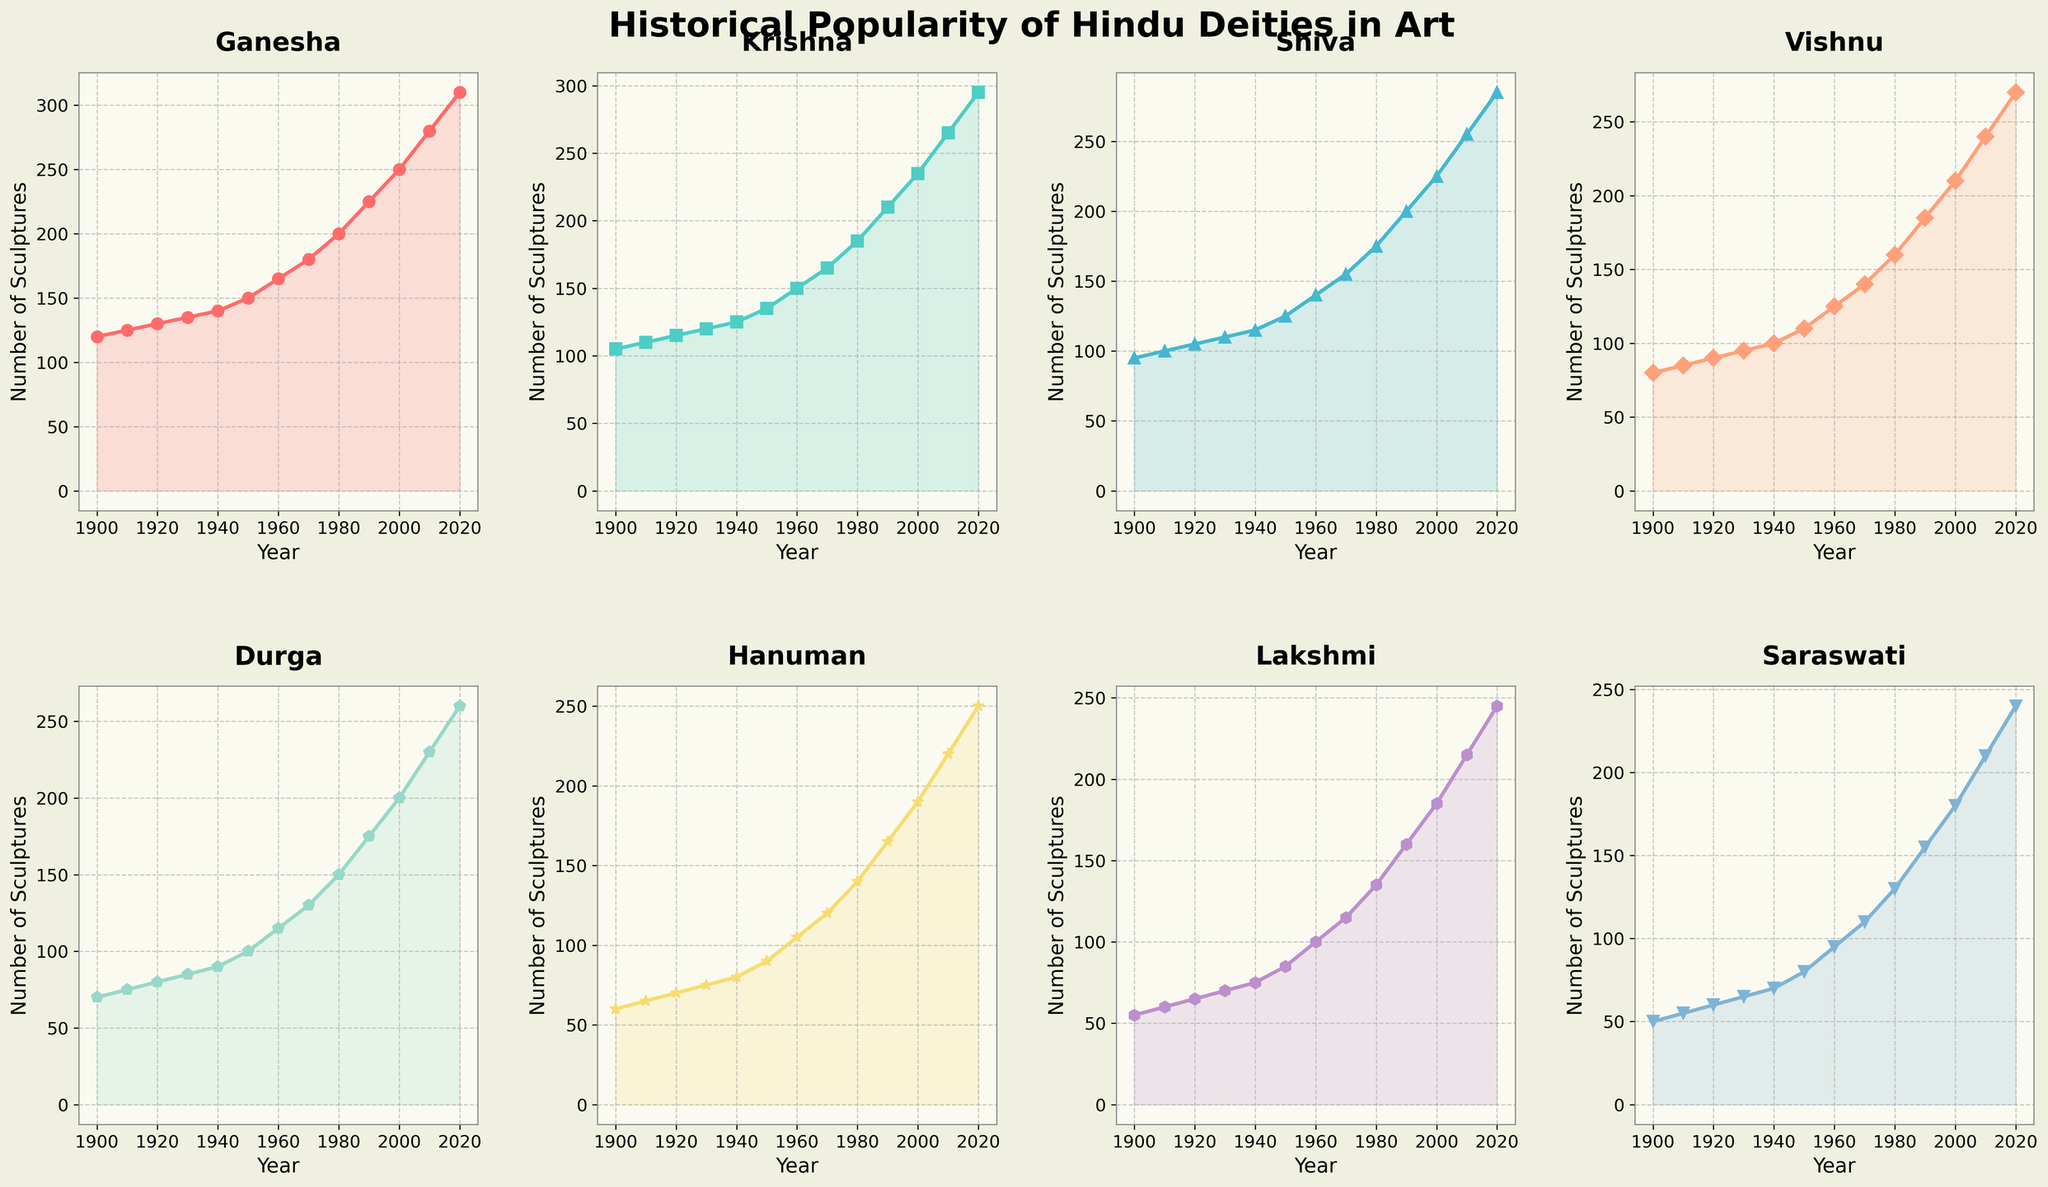what is the average number of Ganesha sculptures created annually between 1990 and 2010? To calculate the average, find the sum of the values of Ganesha sculptures in 1990, 2000, and 2010, then divide by the number of years (three). (225 + 250 + 280) / 3 = 755 / 3 = 251.67
Answer: 251.67 Which deity saw the steepest increase in sculpture creation from 1900 to 2020? By comparing the slopes of the lines, the deity with the steepest increase would have the largest change in values. Ganesha increased from 120 to 310, a difference of 190 sculptures, which is the largest difference among all deities.
Answer: Ganesha Who became more popular more rapidly between Krishna and Shiva after 1950? By looking at the lines for Krishna and Shiva post-1950, Krishna's line rises more sharply than Shiva's. Krishna's count goes from 135 to 295 (an increase of 160), while Shiva's goes from 125 to 285 (an increase of 160). Their rates are equal in this period.
Answer: Both Which two deities had the closest number of sculptures created in the year 2000? Compare the number of sculptures for each deity in the year 2000. Vishnu had 210 sculptures and Durga had 200 sculptures, making them the closest in number.
Answer: Vishnu and Durga In what year did Saraswati surpass 100 sculptures annually? Follow the trend line for Saraswati and find the first year her count crosses 100. Saraswati reaches 100 sculptures in the year 1960.
Answer: 1960 Which deity had the least number of sculptures in 1900 and how many? Looking at the y-values for each deity in 1900, Saraswati had the least with 50 sculptures.
Answer: Saraswati with 50 sculptures By what percentage did the number of Durga sculptures increase from 1900 to 1950? Calculate the percentage increase using the formula [(New Value - Old Value)/Old Value]*100. For Durga: [(100 - 70)/70]*100 = (30/70)*100 ≈ 42.86%
Answer: 42.86% What is the difference between the number of Hanuman sculptures and Lakshmi sculptures in 2020? Subtract the number of Lakshmi sculptures from Hanuman sculptures for 2020. 250 Hans number - 245 Lakshmi number = 5.
Answer: 5 Which year did Lakshmi surpass 100 sculptures annually? Follow the Lakshmi trend line to identify the first year it hits or exceeds 100 sculptures. Lakshmi reaches 100 sculptures in 1960.
Answer: 1960 What is the range in the number of sculptures of Krishna between 1900 and 2020? The range is calculated by subtracting the minimum value from the maximum value. For Krishna, max is 295 in 2020 and min is 105 in 1900. 295 - 105 = 190.
Answer: 190 